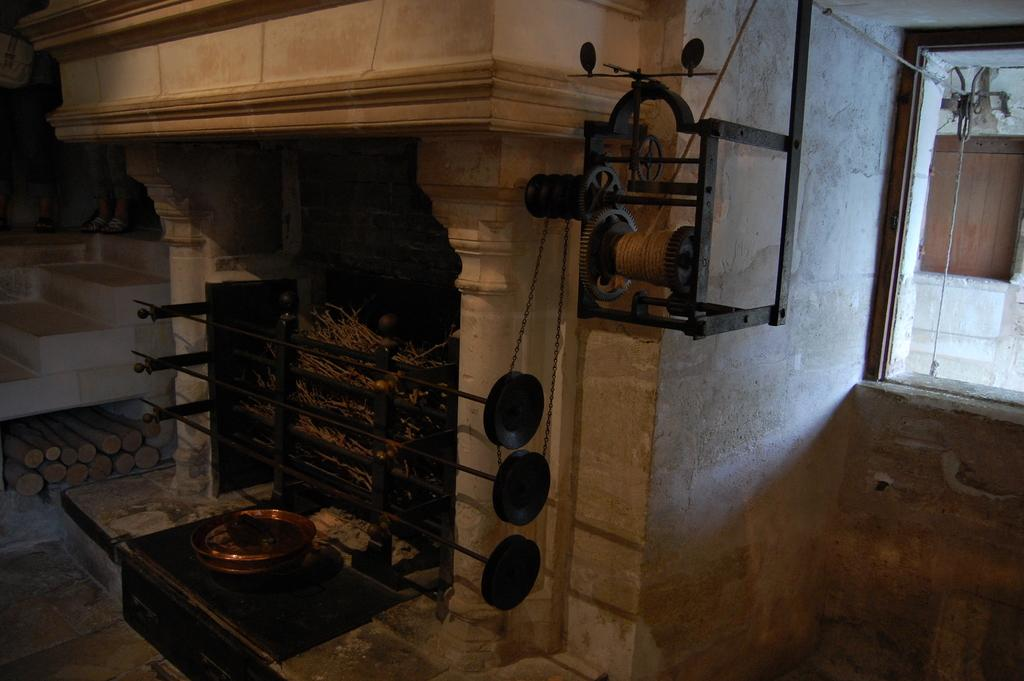What color is the wall in the image? The wall in the image is white. What feature can be seen on the wall? There is a fireplace on the wall in the image. What object is hanging from the ceiling in the image? There is a rope hanging from the ceiling in the image. What type of items are present in the image? There is equipment and an object in the image. What type of advertisement can be seen on the wall in the image? There is no advertisement present on the wall in the image; it only features a white-colored wall with a fireplace. What is the plot of the story being told in the image? The image does not depict a story or plot; it is a static scene with a white-colored wall, a fireplace, a rope, and some equipment and an object. 